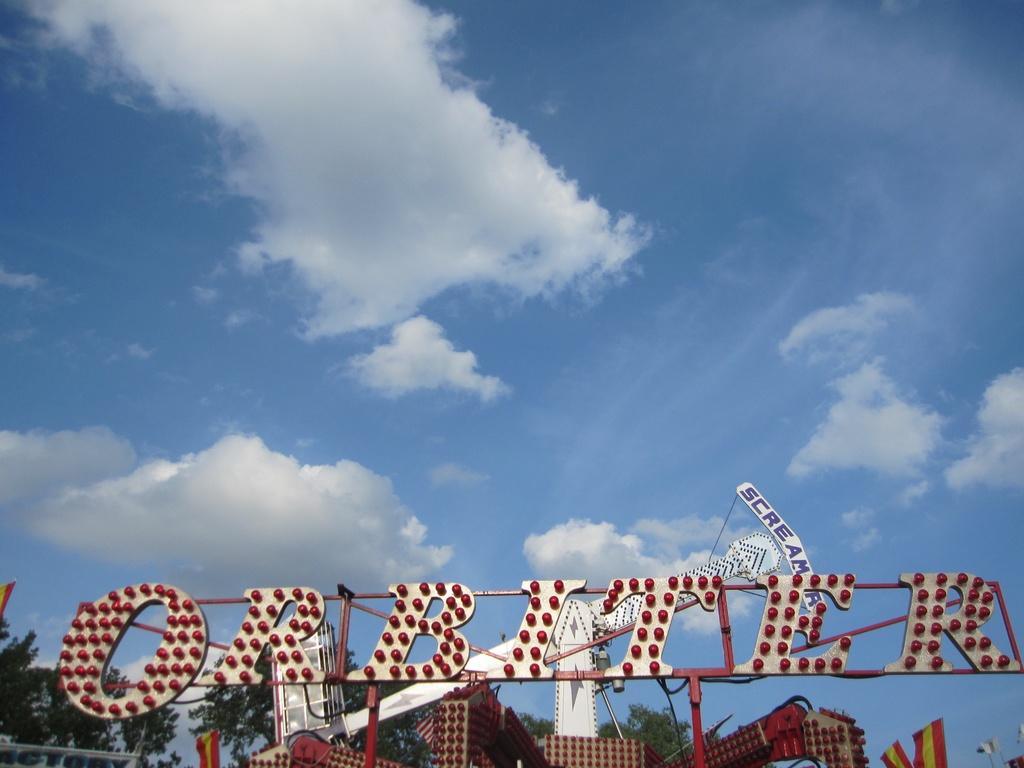Describe this image in one or two sentences. In this image, we can see boards, bulbs, flags and trees and lights. At the top, there are clouds in the sky. 